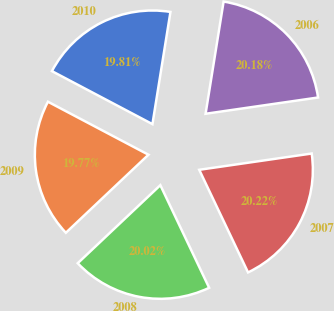Convert chart. <chart><loc_0><loc_0><loc_500><loc_500><pie_chart><fcel>2010<fcel>2009<fcel>2008<fcel>2007<fcel>2006<nl><fcel>19.81%<fcel>19.77%<fcel>20.02%<fcel>20.22%<fcel>20.18%<nl></chart> 